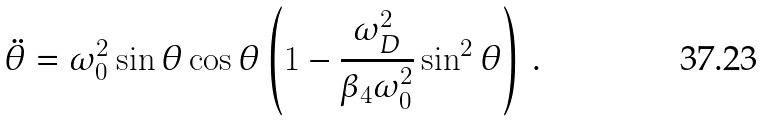<formula> <loc_0><loc_0><loc_500><loc_500>\ddot { \theta } = \omega _ { 0 } ^ { 2 } \sin \theta \cos \theta \left ( 1 - \frac { \omega _ { D } ^ { 2 } } { \beta _ { 4 } \omega _ { 0 } ^ { 2 } } \sin ^ { 2 } \theta \right ) \, .</formula> 